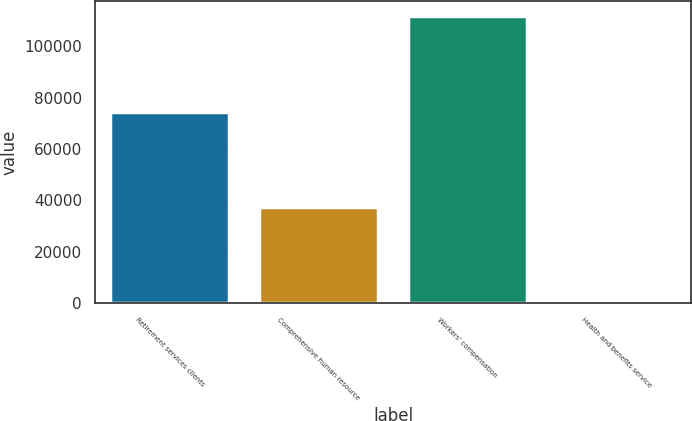Convert chart. <chart><loc_0><loc_0><loc_500><loc_500><bar_chart><fcel>Retirement services clients<fcel>Comprehensive human resource<fcel>Workers' compensation<fcel>Health and benefits service<nl><fcel>74605.1<fcel>37305.8<fcel>111904<fcel>6.4<nl></chart> 